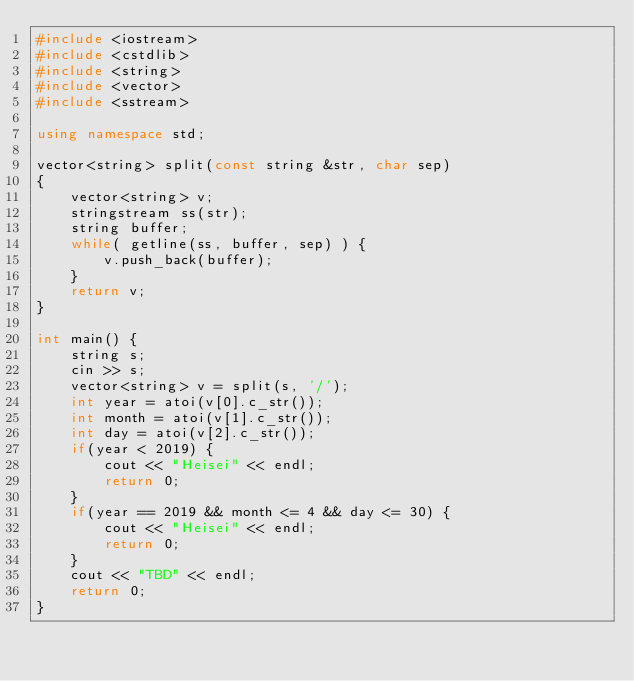Convert code to text. <code><loc_0><loc_0><loc_500><loc_500><_C++_>#include <iostream>
#include <cstdlib>
#include <string>
#include <vector>
#include <sstream>

using namespace std;

vector<string> split(const string &str, char sep)
{
    vector<string> v;
    stringstream ss(str);
    string buffer;
    while( getline(ss, buffer, sep) ) {
        v.push_back(buffer);
    }
    return v;
}

int main() {
    string s;
    cin >> s;
    vector<string> v = split(s, '/');
    int year = atoi(v[0].c_str());
    int month = atoi(v[1].c_str());
    int day = atoi(v[2].c_str());
    if(year < 2019) {
        cout << "Heisei" << endl;
        return 0;
    }
    if(year == 2019 && month <= 4 && day <= 30) {
        cout << "Heisei" << endl;
        return 0;
    }
    cout << "TBD" << endl;
    return 0;
}</code> 